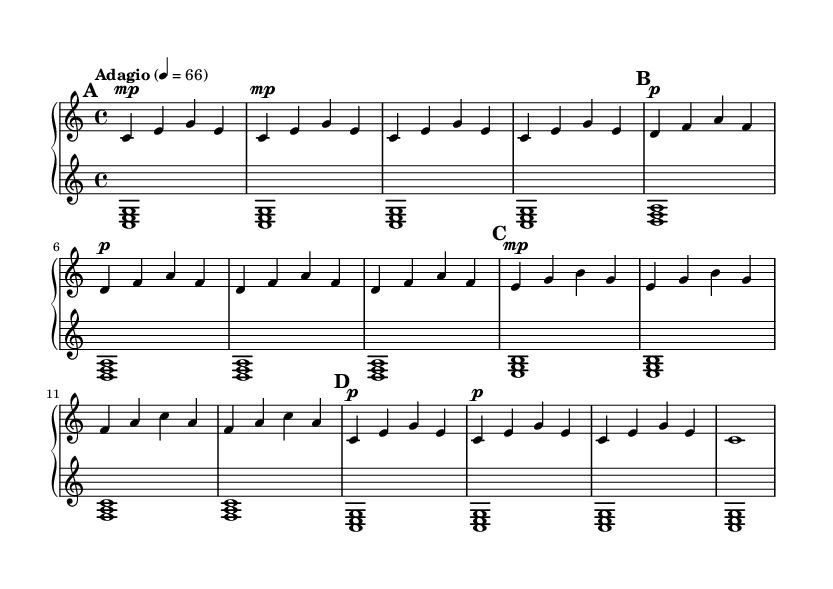What is the key signature of this music? The key signature is indicated at the beginning of the piece and is identified in the global section as C major. C major has no sharps or flats.
Answer: C major What is the time signature of this music? The time signature is found in the global section, specifically noted as 4/4, which means there are four beats in each measure and the quarter note gets one beat.
Answer: 4/4 What tempo marking is specified in the score? The tempo marking is given as "Adagio" with a metronome marking of 4 = 66, indicating a slow tempo where each quarter note is played at 66 beats per minute.
Answer: Adagio How many sections are in the piece? By analyzing the sheet music, particularly the structure outlined in the sections labeled A, A', B, and A'', we can count a total of four distinct sections, including the repeated sections.
Answer: 4 What is the highest note played in the upper staff? Looking through the upper staff, the highest note is A, which appears in Section A'. I can identify it by scanning for the highest pitch indicated in the notation.
Answer: A What type of harmony is used in the lower staff? The harmony in the lower staff is based on triadic chords, specifically major chords as seen in the repeated patterns like <c e g>, <d f a>, which reflect this harmonic structure.
Answer: Triadic major chords How does the music's structure contribute to a calming effect? The structure features simple and repetitive patterns in both the upper and lower staves, with minimal variation, which helps create a tranquil atmosphere typical of minimalist music. The repetition of phrases and consistent harmonic support contribute to this effect.
Answer: Simple and repetitive patterns 